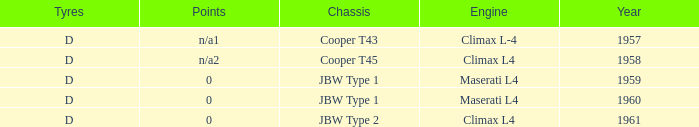What engine was in the year of 1961? Climax L4. 